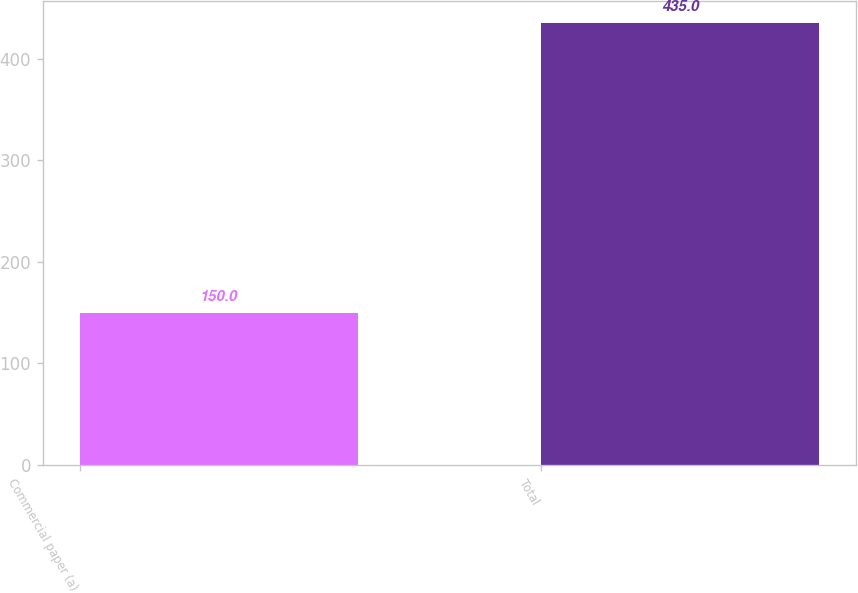Convert chart. <chart><loc_0><loc_0><loc_500><loc_500><bar_chart><fcel>Commercial paper (a)<fcel>Total<nl><fcel>150<fcel>435<nl></chart> 